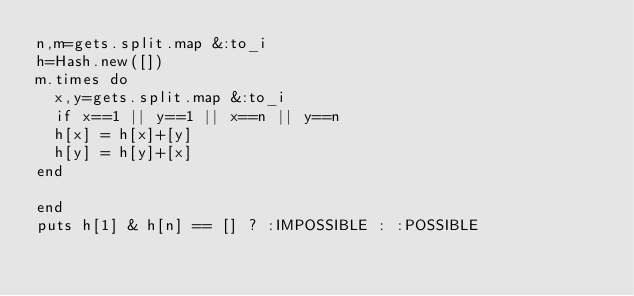Convert code to text. <code><loc_0><loc_0><loc_500><loc_500><_Ruby_>n,m=gets.split.map &:to_i
h=Hash.new([])
m.times do
  x,y=gets.split.map &:to_i
  if x==1 || y==1 || x==n || y==n
  h[x] = h[x]+[y]
  h[y] = h[y]+[x]
end
  
end
puts h[1] & h[n] == [] ? :IMPOSSIBLE : :POSSIBLE
  </code> 